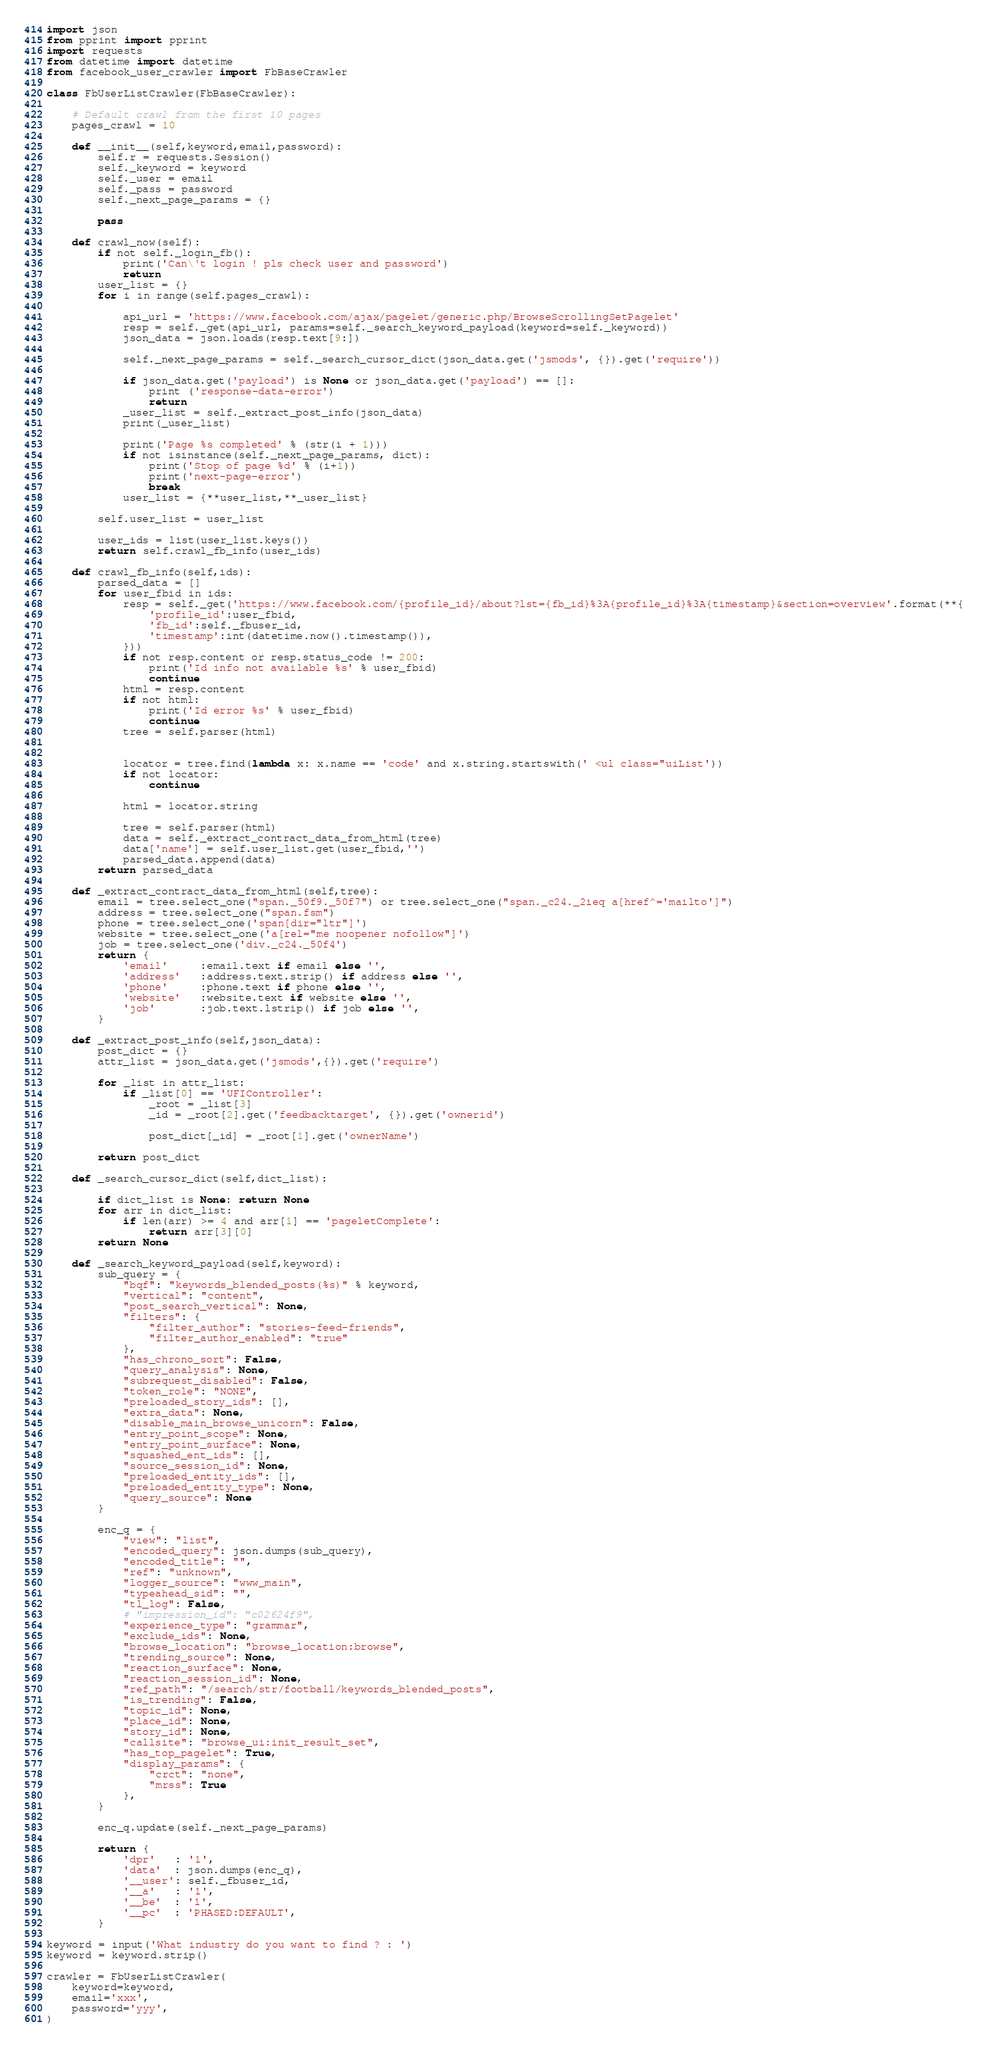Convert code to text. <code><loc_0><loc_0><loc_500><loc_500><_Python_>import json
from pprint import pprint
import requests
from datetime import datetime
from facebook_user_crawler import FbBaseCrawler

class FbUserListCrawler(FbBaseCrawler):
    
    # Default crawl from the first 10 pages
    pages_crawl = 10
    
    def __init__(self,keyword,email,password):
        self.r = requests.Session()
        self._keyword = keyword
        self._user = email
        self._pass = password
        self._next_page_params = {}
        
        pass
    
    def crawl_now(self):
        if not self._login_fb():
            print('Can\'t login ! pls check user and password')
            return
        user_list = {}
        for i in range(self.pages_crawl):
            
            api_url = 'https://www.facebook.com/ajax/pagelet/generic.php/BrowseScrollingSetPagelet'
            resp = self._get(api_url, params=self._search_keyword_payload(keyword=self._keyword))
            json_data = json.loads(resp.text[9:])
            
            self._next_page_params = self._search_cursor_dict(json_data.get('jsmods', {}).get('require'))
            
            if json_data.get('payload') is None or json_data.get('payload') == []:
                print ('response-data-error')
                return
            _user_list = self._extract_post_info(json_data)
            print(_user_list)
            
            print('Page %s completed' % (str(i + 1)))
            if not isinstance(self._next_page_params, dict):
                print('Stop of page %d' % (i+1))
                print('next-page-error')
                break
            user_list = {**user_list,**_user_list}
        
        self.user_list = user_list
        
        user_ids = list(user_list.keys())
        return self.crawl_fb_info(user_ids)
    
    def crawl_fb_info(self,ids):
        parsed_data = []
        for user_fbid in ids:
            resp = self._get('https://www.facebook.com/{profile_id}/about?lst={fb_id}%3A{profile_id}%3A{timestamp}&section=overview'.format(**{
                'profile_id':user_fbid,
                'fb_id':self._fbuser_id,
                'timestamp':int(datetime.now().timestamp()),
            }))
            if not resp.content or resp.status_code != 200:
                print('Id info not available %s' % user_fbid)
                continue
            html = resp.content
            if not html:
                print('Id error %s' % user_fbid)
                continue
            tree = self.parser(html)

            
            locator = tree.find(lambda x: x.name == 'code' and x.string.startswith(' <ul class="uiList'))
            if not locator:
                continue
            
            html = locator.string
            
            tree = self.parser(html)
            data = self._extract_contract_data_from_html(tree)
            data['name'] = self.user_list.get(user_fbid,'')
            parsed_data.append(data)
        return parsed_data
    
    def _extract_contract_data_from_html(self,tree):
        email = tree.select_one("span._50f9._50f7") or tree.select_one("span._c24._2ieq a[href^='mailto']")
        address = tree.select_one("span.fsm")
        phone = tree.select_one('span[dir="ltr"]')
        website = tree.select_one('a[rel="me noopener nofollow"]')
        job = tree.select_one('div._c24._50f4')
        return {
            'email'     :email.text if email else '',
            'address'   :address.text.strip() if address else '',
            'phone'     :phone.text if phone else '',
            'website'   :website.text if website else '',
            'job'       :job.text.lstrip() if job else '',
        }
    
    def _extract_post_info(self,json_data):
        post_dict = {}
        attr_list = json_data.get('jsmods',{}).get('require')
        
        for _list in attr_list:
            if _list[0] == 'UFIController':
                _root = _list[3]
                _id = _root[2].get('feedbacktarget', {}).get('ownerid')
                
                post_dict[_id] = _root[1].get('ownerName')
        
        return post_dict
    
    def _search_cursor_dict(self,dict_list):
        
        if dict_list is None: return None
        for arr in dict_list:
            if len(arr) >= 4 and arr[1] == 'pageletComplete':
                return arr[3][0]
        return None
    
    def _search_keyword_payload(self,keyword):
        sub_query = {
            "bqf": "keywords_blended_posts(%s)" % keyword,
            "vertical": "content",
            "post_search_vertical": None,
            "filters": {
                "filter_author": "stories-feed-friends",
                "filter_author_enabled": "true"
            },
            "has_chrono_sort": False,
            "query_analysis": None,
            "subrequest_disabled": False,
            "token_role": "NONE",
            "preloaded_story_ids": [],
            "extra_data": None,
            "disable_main_browse_unicorn": False,
            "entry_point_scope": None,
            "entry_point_surface": None,
            "squashed_ent_ids": [],
            "source_session_id": None,
            "preloaded_entity_ids": [],
            "preloaded_entity_type": None,
            "query_source": None
        }
        
        enc_q = {
            "view": "list",
            "encoded_query": json.dumps(sub_query),
            "encoded_title": "",
            "ref": "unknown",
            "logger_source": "www_main",
            "typeahead_sid": "",
            "tl_log": False,
            # "impression_id": "c02624f9",
            "experience_type": "grammar",
            "exclude_ids": None,
            "browse_location": "browse_location:browse",
            "trending_source": None,
            "reaction_surface": None,
            "reaction_session_id": None,
            "ref_path": "/search/str/football/keywords_blended_posts",
            "is_trending": False,
            "topic_id": None,
            "place_id": None,
            "story_id": None,
            "callsite": "browse_ui:init_result_set",
            "has_top_pagelet": True,
            "display_params": {
                "crct": "none",
                "mrss": True
            },
        }
        
        enc_q.update(self._next_page_params)
        
        return {
            'dpr'   : '1',
            'data'  : json.dumps(enc_q),
            '__user': self._fbuser_id,
            '__a'   : '1',
            '__be'  : '1',
            '__pc'  : 'PHASED:DEFAULT',
        }

keyword = input('What industry do you want to find ? : ')
keyword = keyword.strip()

crawler = FbUserListCrawler(
    keyword=keyword,
    email='xxx',
    password='yyy',
)</code> 